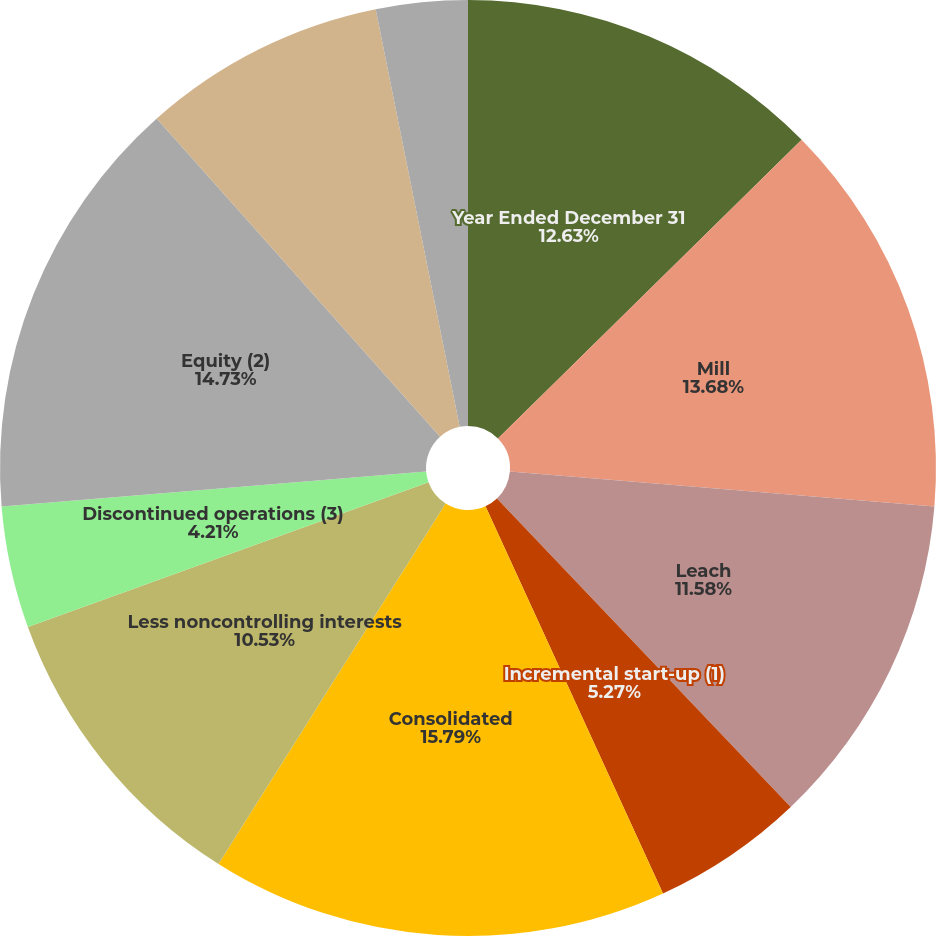Convert chart to OTSL. <chart><loc_0><loc_0><loc_500><loc_500><pie_chart><fcel>Year Ended December 31<fcel>Mill<fcel>Leach<fcel>Incremental start-up (1)<fcel>Consolidated<fcel>Less noncontrolling interests<fcel>Discontinued operations (3)<fcel>Equity (2)<fcel>Direct mining and production<fcel>By-product credits<nl><fcel>12.63%<fcel>13.68%<fcel>11.58%<fcel>5.27%<fcel>15.79%<fcel>10.53%<fcel>4.21%<fcel>14.73%<fcel>8.42%<fcel>3.16%<nl></chart> 